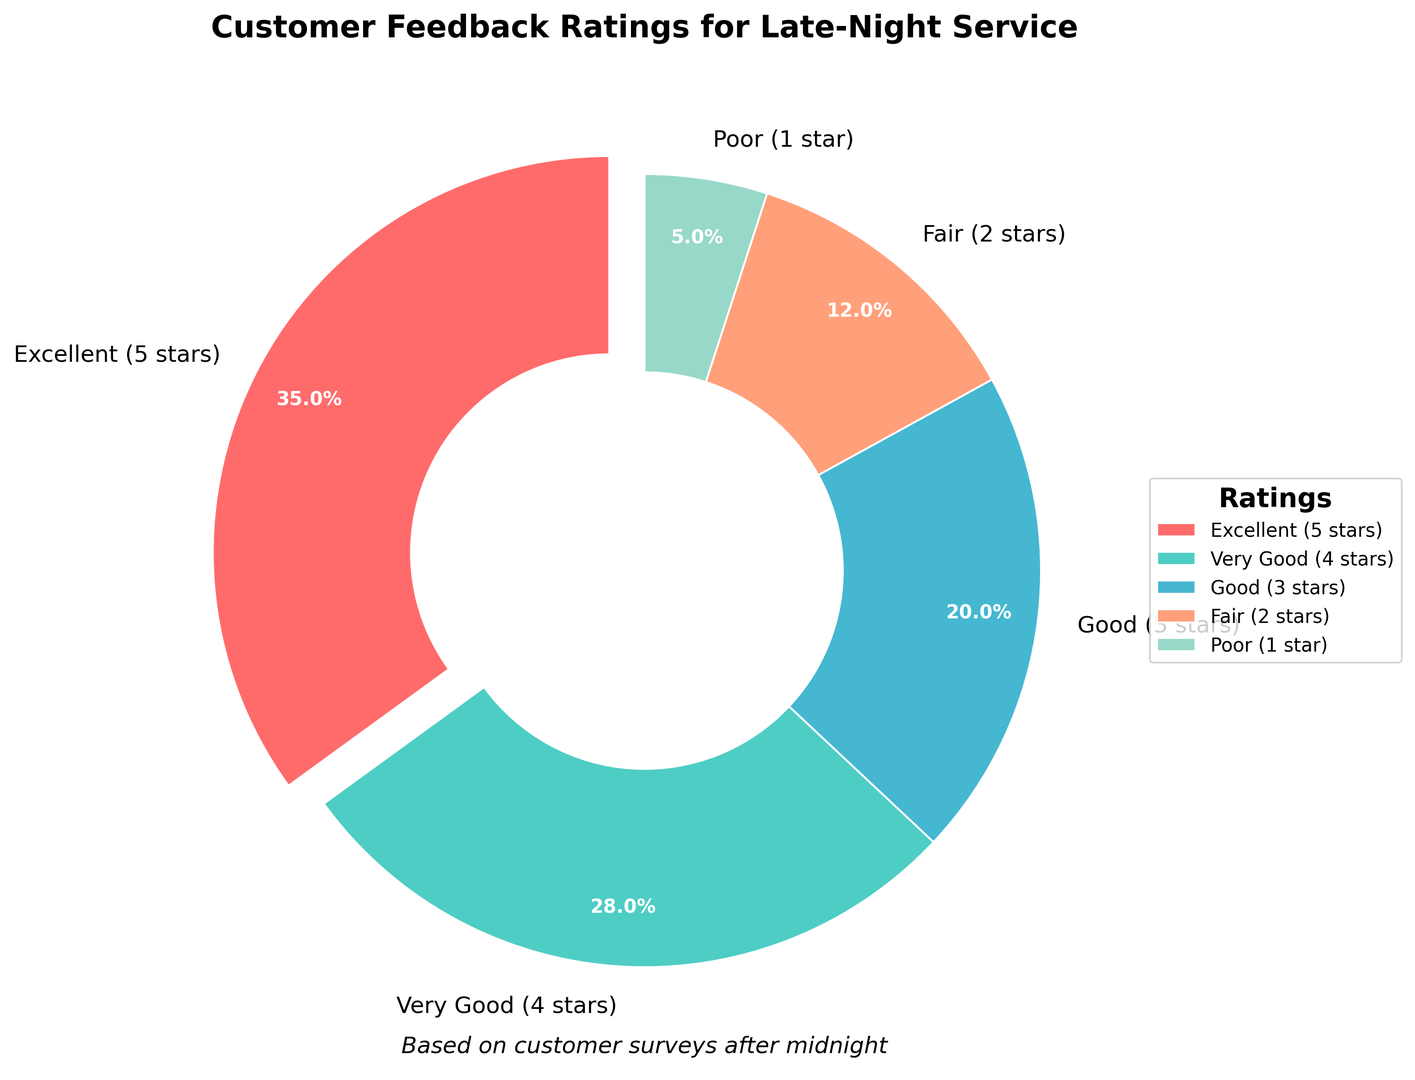Which rating category received the highest percentage of customer feedback? Look at the pie chart and find the slice with the largest percentage. The slice labeled "Excellent (5 stars)" has the highest percentage at 35%.
Answer: Excellent (5 stars) Which rating category has the smallest proportion of feedback? Check the pie chart for the slice with the smallest percentage. The slice labeled "Poor (1 star)" has the smallest proportion at 5%.
Answer: Poor (1 star) What is the combined percentage of the top two rating categories? The top two rating categories are "Excellent (5 stars)" with 35% and "Very Good (4 stars)" with 28%. Summing these percentages gives 35% + 28% = 63%.
Answer: 63% How much larger is the percentage of "Good (3 stars)" compared to "Fair (2 stars)"? The percentage for "Good (3 stars)" is 20%, and for "Fair (2 stars)" it is 12%. The difference is 20% - 12% = 8%.
Answer: 8% Arrange the rating categories in decreasing order based on their percentage of feedback. List each rating category by their percentage from highest to lowest: Excellent (5 stars) - 35%, Very Good (4 stars) - 28%, Good (3 stars) - 20%, Fair (2 stars) - 12%, Poor (1 star) - 5%.
Answer: Excellent (5 stars), Very Good (4 stars), Good (3 stars), Fair (2 stars), Poor (1 star) What percentage of feedback is below "Good (3 stars)"? Ratings below "Good (3 stars)" are "Fair (2 stars)" and "Poor (1 star)". Summing their percentages gives 12% + 5% = 17%.
Answer: 17% Is the percentage of "Very Good (4 stars)" ratings more than double that of the "Poor (1 star)" ratings? The percentage for "Very Good (4 stars)" is 28%, and for "Poor (1 star)" it is 5%. Doubling the "Poor (1 star)" percentage gives 5% * 2 = 10%, and 28% is more than 10%.
Answer: Yes If a new survey added 10% more feedback to the "Excellent (5 stars)" category, what would be the new percentage for that category? Currently, "Excellent (5 stars)" is at 35%. Adding 10% of total gives 35% + 10% = 45%.
Answer: 45% What two rating categories make up more than half of all feedback combined? Check the pie chart to find the combined percentage of the top categories. "Excellent (5 stars)" is 35% and "Very Good (4 stars)" is 28%, combined they are 35% + 28% = 63%, which is more than half.
Answer: Excellent (5 stars) and Very Good (4 stars) What is the difference in feedback percentage between the highest and lowest rated categories? The highest rated category is "Excellent (5 stars)" at 35%, and the lowest is "Poor (1 star)" at 5%. The difference is 35% - 5% = 30%.
Answer: 30% 